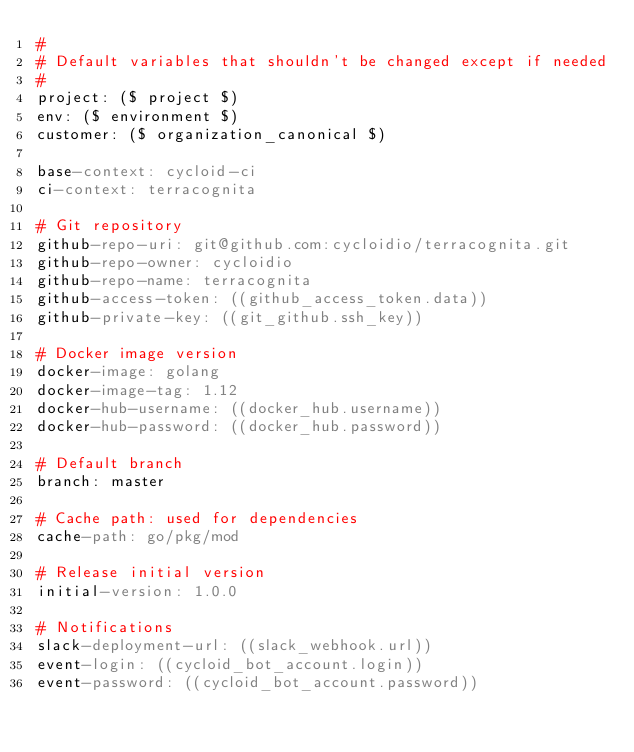<code> <loc_0><loc_0><loc_500><loc_500><_YAML_>#
# Default variables that shouldn't be changed except if needed
#
project: ($ project $)
env: ($ environment $)
customer: ($ organization_canonical $)

base-context: cycloid-ci
ci-context: terracognita

# Git repository
github-repo-uri: git@github.com:cycloidio/terracognita.git
github-repo-owner: cycloidio
github-repo-name: terracognita
github-access-token: ((github_access_token.data))
github-private-key: ((git_github.ssh_key))

# Docker image version
docker-image: golang
docker-image-tag: 1.12
docker-hub-username: ((docker_hub.username))
docker-hub-password: ((docker_hub.password))

# Default branch
branch: master

# Cache path: used for dependencies
cache-path: go/pkg/mod

# Release initial version
initial-version: 1.0.0

# Notifications
slack-deployment-url: ((slack_webhook.url))
event-login: ((cycloid_bot_account.login))
event-password: ((cycloid_bot_account.password))</code> 